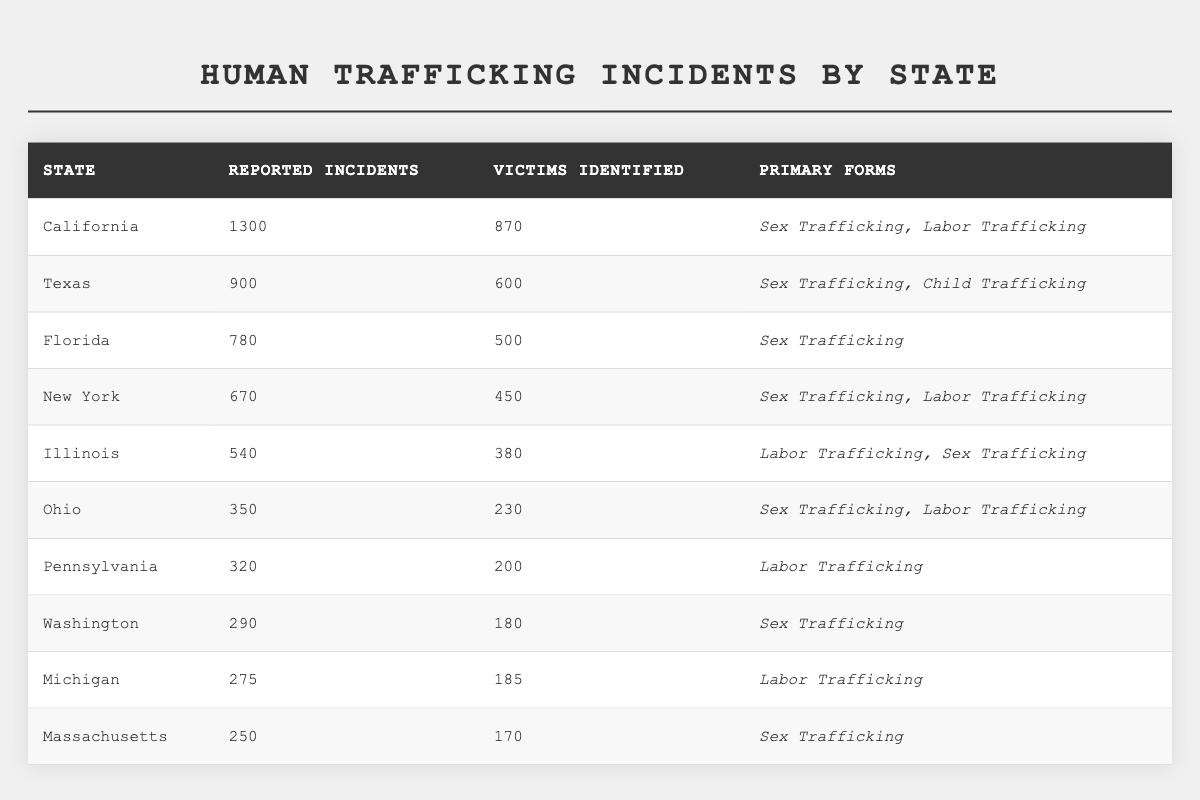What state has the highest number of reported human trafficking incidents? California has 1300 reported incidents, which is the highest among all states listed in the table.
Answer: California How many victims were identified in Texas? According to the table, Texas has 600 victims identified in connection with human trafficking incidents.
Answer: 600 What is the total number of reported human trafficking incidents across all states? By adding the reported incidents: 1300 + 900 + 780 + 670 + 540 + 350 + 320 + 290 + 275 + 250 = 5,075; thus, the total number of reported incidents is 5,075.
Answer: 5075 Which state has the lowest number of victims identified, and how many are there? Massachusetts has the lowest number of victims identified at 170, as per the data in the table.
Answer: Massachusetts, 170 Is Illinois a state where sex trafficking is reported? Yes, the table indicates that Illinois has reported incidents of both Labor Trafficking and Sex Trafficking.
Answer: Yes How many more reported incidents does California have compared to Florida? To find the difference, subtract Florida’s 780 reported incidents from California’s 1300 reported incidents: 1300 - 780 = 520. Thus, California has 520 more reported incidents than Florida.
Answer: 520 What's the average number of victims identified across all states? Adding the victims identified gives: 870 + 600 + 500 + 450 + 380 + 230 + 200 + 180 + 185 + 170 = 3,965. There are 10 states, so dividing gives: 3,965 / 10 = 396.5, so the average number of victims identified is 396.5.
Answer: 396.5 Which two states have identical primary forms of trafficking reported? The primary forms for California and New York include Sex Trafficking along with other forms (Labor Trafficking for New York and Labor Trafficking for California). Therefore, they share a common primary form, but not identical combinations.
Answer: No identical combinations What percentage of reported incidents in Pennsylvania involves Labor Trafficking? In Pennsylvania, there are 320 reported incidents, all of which are attributed to Labor Trafficking. Thus, the percentage is (320 / 320) * 100 = 100%.
Answer: 100% How many states report incidents predominantly involving Labor Trafficking? The states indicating Labor Trafficking as a primary form include Illinois, Ohio, Pennsylvania, Washington, and Michigan. This totals 5 states that report incidents predominantly involving Labor Trafficking.
Answer: 5 